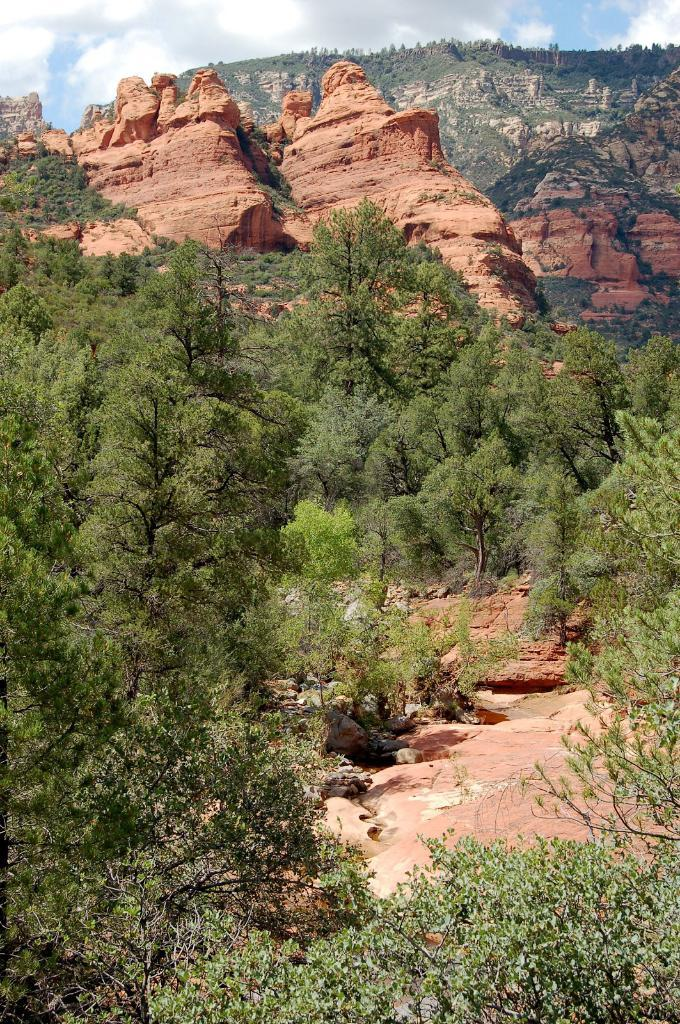What type of natural environment is depicted in the image? The image features many trees, indicating a forest or wooded area. What can be seen in the distance in the image? There is a mountain visible in the background of the image. What type of instrument can be heard playing on the seashore in the image? There is no seashore or instrument present in the image; it features a forest or wooded area with a mountain in the background. 